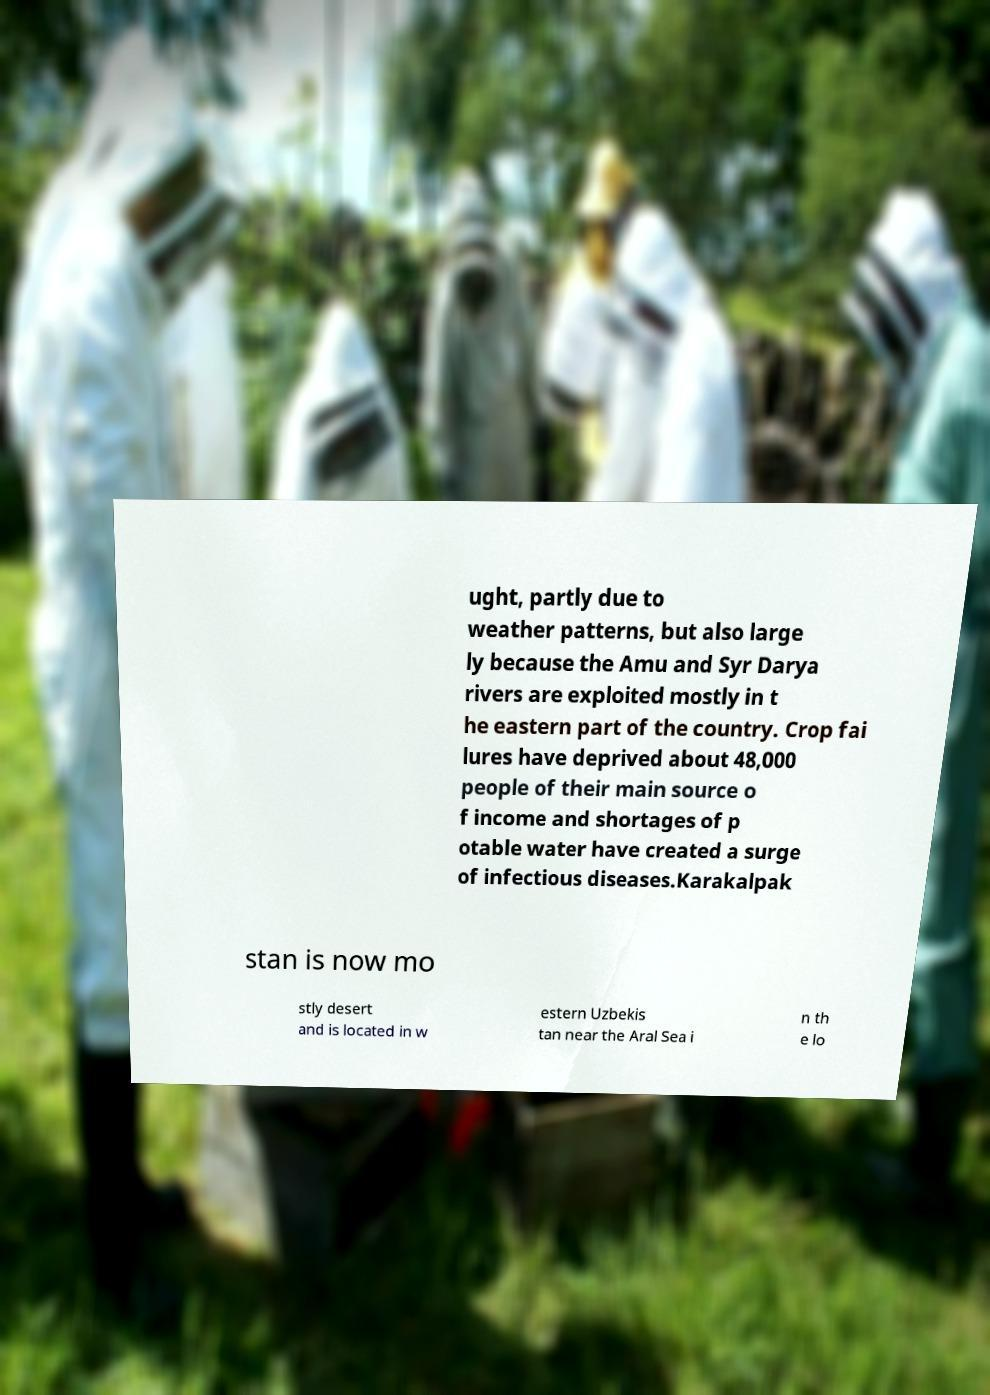What messages or text are displayed in this image? I need them in a readable, typed format. ught, partly due to weather patterns, but also large ly because the Amu and Syr Darya rivers are exploited mostly in t he eastern part of the country. Crop fai lures have deprived about 48,000 people of their main source o f income and shortages of p otable water have created a surge of infectious diseases.Karakalpak stan is now mo stly desert and is located in w estern Uzbekis tan near the Aral Sea i n th e lo 